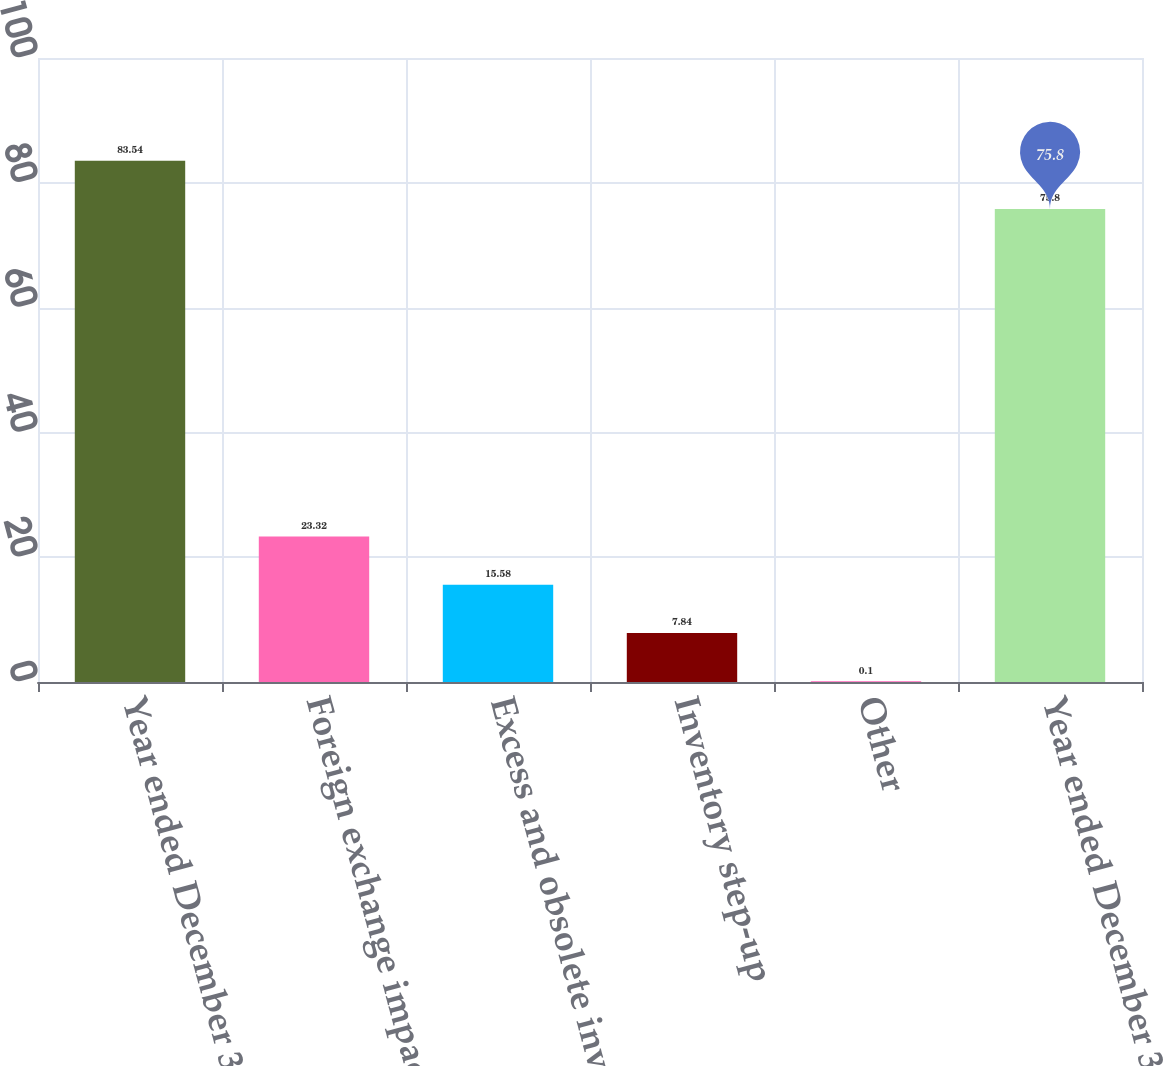<chart> <loc_0><loc_0><loc_500><loc_500><bar_chart><fcel>Year ended December 31 2007<fcel>Foreign exchange impact net<fcel>Excess and obsolete inventory<fcel>Inventory step-up<fcel>Other<fcel>Year ended December 31 2008<nl><fcel>83.54<fcel>23.32<fcel>15.58<fcel>7.84<fcel>0.1<fcel>75.8<nl></chart> 